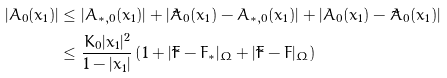Convert formula to latex. <formula><loc_0><loc_0><loc_500><loc_500>| A _ { 0 } ( x _ { 1 } ) | & \leq | A _ { * , 0 } ( x _ { 1 } ) | + | \tilde { A } _ { 0 } ( x _ { 1 } ) - A _ { * , 0 } ( x _ { 1 } ) | + | A _ { 0 } ( x _ { 1 } ) - \tilde { A } _ { 0 } ( x _ { 1 } ) | \\ & \leq \frac { K _ { 0 } | x _ { 1 } | ^ { 2 } } { 1 - | x _ { 1 } | } \left ( 1 + | \tilde { F } - F _ { * } | _ { \Omega } + | \tilde { F } - F | _ { \Omega } \right )</formula> 